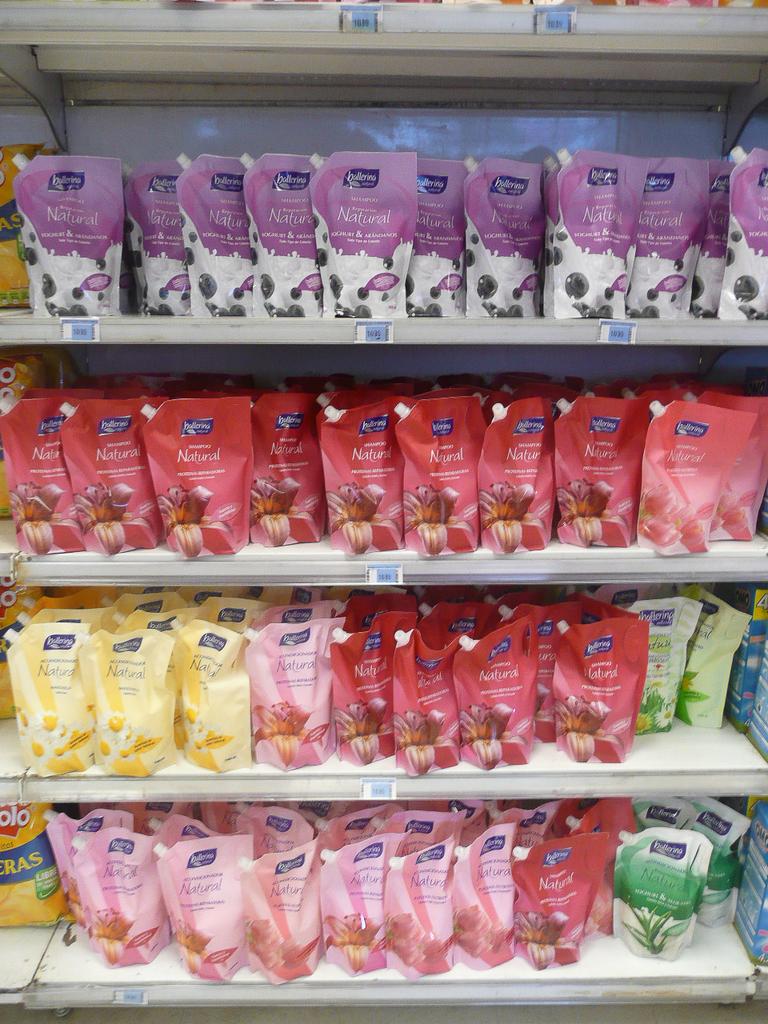Are some of these natural?
Give a very brief answer. Yes. Are they for cats to eat?
Your response must be concise. No. 